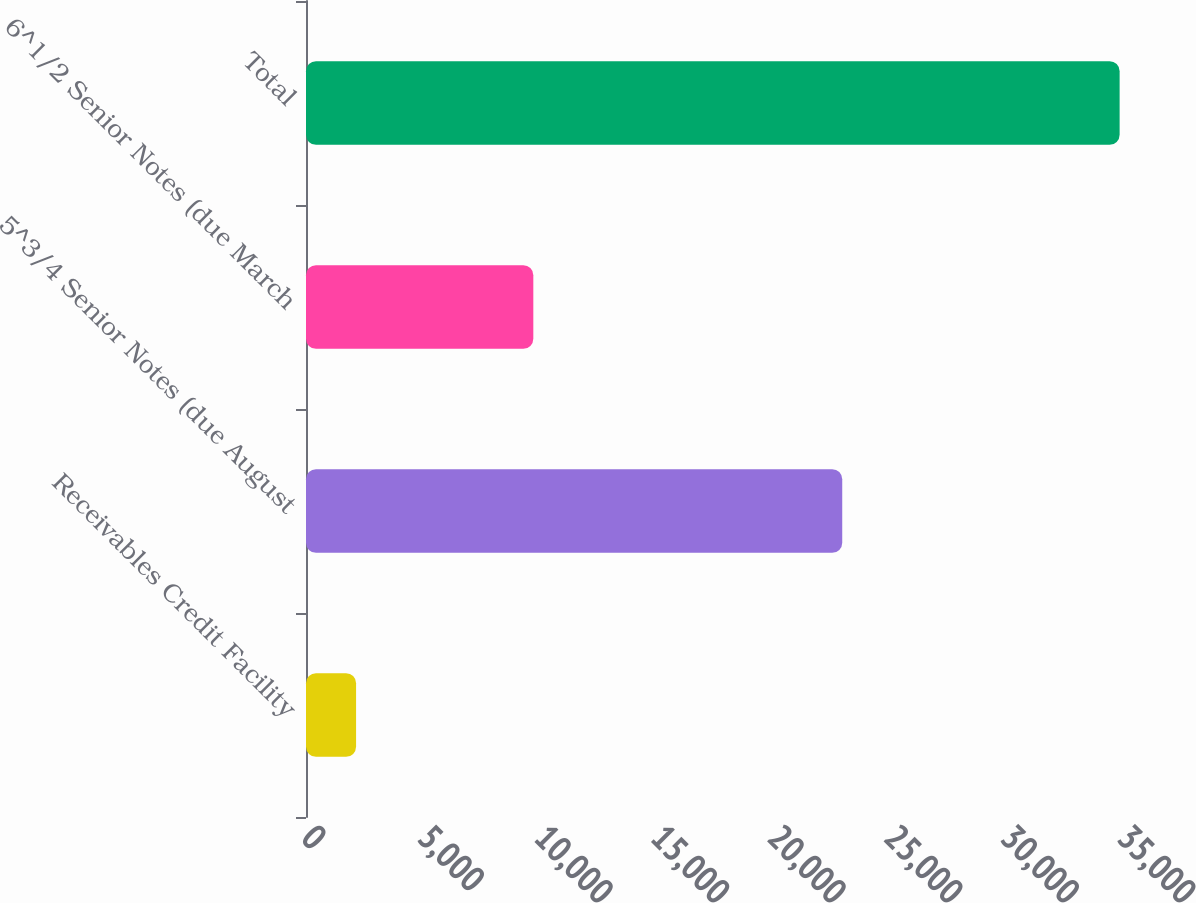Convert chart to OTSL. <chart><loc_0><loc_0><loc_500><loc_500><bar_chart><fcel>Receivables Credit Facility<fcel>5^3/4 Senior Notes (due August<fcel>6^1/2 Senior Notes (due March<fcel>Total<nl><fcel>2148<fcel>23000<fcel>9750<fcel>34898<nl></chart> 